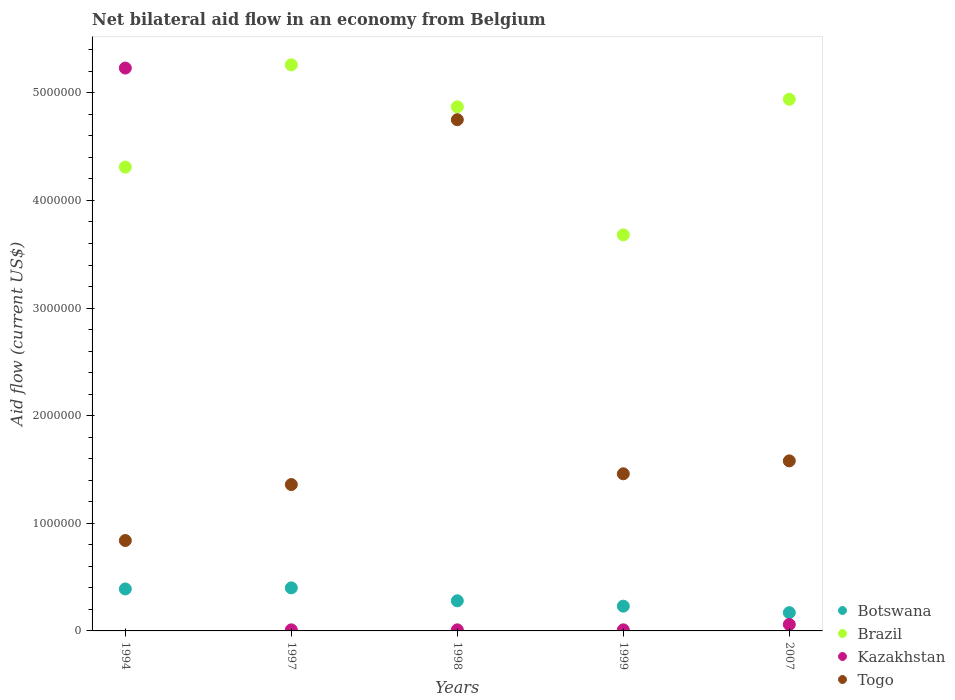Is the number of dotlines equal to the number of legend labels?
Keep it short and to the point. Yes. Across all years, what is the maximum net bilateral aid flow in Kazakhstan?
Keep it short and to the point. 5.23e+06. Across all years, what is the minimum net bilateral aid flow in Botswana?
Offer a very short reply. 1.70e+05. What is the total net bilateral aid flow in Kazakhstan in the graph?
Ensure brevity in your answer.  5.32e+06. What is the difference between the net bilateral aid flow in Botswana in 1994 and that in 1999?
Make the answer very short. 1.60e+05. What is the difference between the net bilateral aid flow in Kazakhstan in 1997 and the net bilateral aid flow in Brazil in 1999?
Your response must be concise. -3.67e+06. What is the average net bilateral aid flow in Kazakhstan per year?
Your answer should be very brief. 1.06e+06. In the year 1997, what is the difference between the net bilateral aid flow in Kazakhstan and net bilateral aid flow in Brazil?
Ensure brevity in your answer.  -5.25e+06. What is the ratio of the net bilateral aid flow in Brazil in 1999 to that in 2007?
Your response must be concise. 0.74. Is the net bilateral aid flow in Kazakhstan in 1994 less than that in 1997?
Your answer should be compact. No. What is the difference between the highest and the lowest net bilateral aid flow in Brazil?
Ensure brevity in your answer.  1.58e+06. Is it the case that in every year, the sum of the net bilateral aid flow in Togo and net bilateral aid flow in Brazil  is greater than the sum of net bilateral aid flow in Kazakhstan and net bilateral aid flow in Botswana?
Offer a very short reply. No. Is it the case that in every year, the sum of the net bilateral aid flow in Botswana and net bilateral aid flow in Kazakhstan  is greater than the net bilateral aid flow in Togo?
Give a very brief answer. No. Does the net bilateral aid flow in Kazakhstan monotonically increase over the years?
Your response must be concise. No. Is the net bilateral aid flow in Botswana strictly greater than the net bilateral aid flow in Togo over the years?
Make the answer very short. No. Is the net bilateral aid flow in Botswana strictly less than the net bilateral aid flow in Togo over the years?
Offer a terse response. Yes. How many dotlines are there?
Offer a very short reply. 4. How many years are there in the graph?
Your answer should be very brief. 5. Are the values on the major ticks of Y-axis written in scientific E-notation?
Your answer should be compact. No. Does the graph contain any zero values?
Offer a terse response. No. How many legend labels are there?
Keep it short and to the point. 4. How are the legend labels stacked?
Ensure brevity in your answer.  Vertical. What is the title of the graph?
Offer a very short reply. Net bilateral aid flow in an economy from Belgium. What is the label or title of the Y-axis?
Your response must be concise. Aid flow (current US$). What is the Aid flow (current US$) in Botswana in 1994?
Your response must be concise. 3.90e+05. What is the Aid flow (current US$) in Brazil in 1994?
Provide a succinct answer. 4.31e+06. What is the Aid flow (current US$) in Kazakhstan in 1994?
Give a very brief answer. 5.23e+06. What is the Aid flow (current US$) in Togo in 1994?
Make the answer very short. 8.40e+05. What is the Aid flow (current US$) of Botswana in 1997?
Your answer should be very brief. 4.00e+05. What is the Aid flow (current US$) of Brazil in 1997?
Provide a short and direct response. 5.26e+06. What is the Aid flow (current US$) in Togo in 1997?
Make the answer very short. 1.36e+06. What is the Aid flow (current US$) of Botswana in 1998?
Your answer should be compact. 2.80e+05. What is the Aid flow (current US$) of Brazil in 1998?
Provide a short and direct response. 4.87e+06. What is the Aid flow (current US$) in Kazakhstan in 1998?
Give a very brief answer. 10000. What is the Aid flow (current US$) of Togo in 1998?
Your answer should be compact. 4.75e+06. What is the Aid flow (current US$) in Brazil in 1999?
Offer a very short reply. 3.68e+06. What is the Aid flow (current US$) of Togo in 1999?
Offer a terse response. 1.46e+06. What is the Aid flow (current US$) of Botswana in 2007?
Your response must be concise. 1.70e+05. What is the Aid flow (current US$) in Brazil in 2007?
Provide a succinct answer. 4.94e+06. What is the Aid flow (current US$) of Togo in 2007?
Keep it short and to the point. 1.58e+06. Across all years, what is the maximum Aid flow (current US$) of Brazil?
Provide a short and direct response. 5.26e+06. Across all years, what is the maximum Aid flow (current US$) of Kazakhstan?
Give a very brief answer. 5.23e+06. Across all years, what is the maximum Aid flow (current US$) in Togo?
Give a very brief answer. 4.75e+06. Across all years, what is the minimum Aid flow (current US$) of Brazil?
Your response must be concise. 3.68e+06. Across all years, what is the minimum Aid flow (current US$) in Kazakhstan?
Your response must be concise. 10000. Across all years, what is the minimum Aid flow (current US$) in Togo?
Provide a succinct answer. 8.40e+05. What is the total Aid flow (current US$) of Botswana in the graph?
Provide a succinct answer. 1.47e+06. What is the total Aid flow (current US$) of Brazil in the graph?
Your answer should be compact. 2.31e+07. What is the total Aid flow (current US$) in Kazakhstan in the graph?
Offer a terse response. 5.32e+06. What is the total Aid flow (current US$) of Togo in the graph?
Provide a short and direct response. 9.99e+06. What is the difference between the Aid flow (current US$) in Brazil in 1994 and that in 1997?
Your answer should be compact. -9.50e+05. What is the difference between the Aid flow (current US$) of Kazakhstan in 1994 and that in 1997?
Provide a short and direct response. 5.22e+06. What is the difference between the Aid flow (current US$) in Togo in 1994 and that in 1997?
Ensure brevity in your answer.  -5.20e+05. What is the difference between the Aid flow (current US$) in Botswana in 1994 and that in 1998?
Keep it short and to the point. 1.10e+05. What is the difference between the Aid flow (current US$) of Brazil in 1994 and that in 1998?
Make the answer very short. -5.60e+05. What is the difference between the Aid flow (current US$) in Kazakhstan in 1994 and that in 1998?
Give a very brief answer. 5.22e+06. What is the difference between the Aid flow (current US$) of Togo in 1994 and that in 1998?
Provide a succinct answer. -3.91e+06. What is the difference between the Aid flow (current US$) of Brazil in 1994 and that in 1999?
Your response must be concise. 6.30e+05. What is the difference between the Aid flow (current US$) in Kazakhstan in 1994 and that in 1999?
Offer a very short reply. 5.22e+06. What is the difference between the Aid flow (current US$) of Togo in 1994 and that in 1999?
Offer a very short reply. -6.20e+05. What is the difference between the Aid flow (current US$) in Botswana in 1994 and that in 2007?
Ensure brevity in your answer.  2.20e+05. What is the difference between the Aid flow (current US$) in Brazil in 1994 and that in 2007?
Provide a short and direct response. -6.30e+05. What is the difference between the Aid flow (current US$) in Kazakhstan in 1994 and that in 2007?
Give a very brief answer. 5.17e+06. What is the difference between the Aid flow (current US$) of Togo in 1994 and that in 2007?
Offer a very short reply. -7.40e+05. What is the difference between the Aid flow (current US$) in Botswana in 1997 and that in 1998?
Ensure brevity in your answer.  1.20e+05. What is the difference between the Aid flow (current US$) in Togo in 1997 and that in 1998?
Your answer should be compact. -3.39e+06. What is the difference between the Aid flow (current US$) of Brazil in 1997 and that in 1999?
Make the answer very short. 1.58e+06. What is the difference between the Aid flow (current US$) of Kazakhstan in 1997 and that in 1999?
Offer a terse response. 0. What is the difference between the Aid flow (current US$) in Togo in 1997 and that in 1999?
Offer a terse response. -1.00e+05. What is the difference between the Aid flow (current US$) in Botswana in 1997 and that in 2007?
Give a very brief answer. 2.30e+05. What is the difference between the Aid flow (current US$) of Kazakhstan in 1997 and that in 2007?
Give a very brief answer. -5.00e+04. What is the difference between the Aid flow (current US$) of Brazil in 1998 and that in 1999?
Offer a terse response. 1.19e+06. What is the difference between the Aid flow (current US$) of Togo in 1998 and that in 1999?
Provide a short and direct response. 3.29e+06. What is the difference between the Aid flow (current US$) of Togo in 1998 and that in 2007?
Offer a terse response. 3.17e+06. What is the difference between the Aid flow (current US$) of Botswana in 1999 and that in 2007?
Give a very brief answer. 6.00e+04. What is the difference between the Aid flow (current US$) in Brazil in 1999 and that in 2007?
Give a very brief answer. -1.26e+06. What is the difference between the Aid flow (current US$) in Kazakhstan in 1999 and that in 2007?
Make the answer very short. -5.00e+04. What is the difference between the Aid flow (current US$) in Togo in 1999 and that in 2007?
Provide a short and direct response. -1.20e+05. What is the difference between the Aid flow (current US$) of Botswana in 1994 and the Aid flow (current US$) of Brazil in 1997?
Offer a very short reply. -4.87e+06. What is the difference between the Aid flow (current US$) of Botswana in 1994 and the Aid flow (current US$) of Togo in 1997?
Provide a succinct answer. -9.70e+05. What is the difference between the Aid flow (current US$) in Brazil in 1994 and the Aid flow (current US$) in Kazakhstan in 1997?
Provide a short and direct response. 4.30e+06. What is the difference between the Aid flow (current US$) in Brazil in 1994 and the Aid flow (current US$) in Togo in 1997?
Your response must be concise. 2.95e+06. What is the difference between the Aid flow (current US$) of Kazakhstan in 1994 and the Aid flow (current US$) of Togo in 1997?
Make the answer very short. 3.87e+06. What is the difference between the Aid flow (current US$) of Botswana in 1994 and the Aid flow (current US$) of Brazil in 1998?
Your answer should be compact. -4.48e+06. What is the difference between the Aid flow (current US$) of Botswana in 1994 and the Aid flow (current US$) of Kazakhstan in 1998?
Offer a terse response. 3.80e+05. What is the difference between the Aid flow (current US$) in Botswana in 1994 and the Aid flow (current US$) in Togo in 1998?
Ensure brevity in your answer.  -4.36e+06. What is the difference between the Aid flow (current US$) of Brazil in 1994 and the Aid flow (current US$) of Kazakhstan in 1998?
Offer a terse response. 4.30e+06. What is the difference between the Aid flow (current US$) of Brazil in 1994 and the Aid flow (current US$) of Togo in 1998?
Your response must be concise. -4.40e+05. What is the difference between the Aid flow (current US$) of Botswana in 1994 and the Aid flow (current US$) of Brazil in 1999?
Offer a very short reply. -3.29e+06. What is the difference between the Aid flow (current US$) in Botswana in 1994 and the Aid flow (current US$) in Kazakhstan in 1999?
Offer a terse response. 3.80e+05. What is the difference between the Aid flow (current US$) in Botswana in 1994 and the Aid flow (current US$) in Togo in 1999?
Your answer should be compact. -1.07e+06. What is the difference between the Aid flow (current US$) of Brazil in 1994 and the Aid flow (current US$) of Kazakhstan in 1999?
Provide a short and direct response. 4.30e+06. What is the difference between the Aid flow (current US$) of Brazil in 1994 and the Aid flow (current US$) of Togo in 1999?
Offer a very short reply. 2.85e+06. What is the difference between the Aid flow (current US$) in Kazakhstan in 1994 and the Aid flow (current US$) in Togo in 1999?
Give a very brief answer. 3.77e+06. What is the difference between the Aid flow (current US$) in Botswana in 1994 and the Aid flow (current US$) in Brazil in 2007?
Provide a succinct answer. -4.55e+06. What is the difference between the Aid flow (current US$) of Botswana in 1994 and the Aid flow (current US$) of Togo in 2007?
Make the answer very short. -1.19e+06. What is the difference between the Aid flow (current US$) in Brazil in 1994 and the Aid flow (current US$) in Kazakhstan in 2007?
Make the answer very short. 4.25e+06. What is the difference between the Aid flow (current US$) of Brazil in 1994 and the Aid flow (current US$) of Togo in 2007?
Give a very brief answer. 2.73e+06. What is the difference between the Aid flow (current US$) of Kazakhstan in 1994 and the Aid flow (current US$) of Togo in 2007?
Your answer should be very brief. 3.65e+06. What is the difference between the Aid flow (current US$) of Botswana in 1997 and the Aid flow (current US$) of Brazil in 1998?
Keep it short and to the point. -4.47e+06. What is the difference between the Aid flow (current US$) in Botswana in 1997 and the Aid flow (current US$) in Togo in 1998?
Your response must be concise. -4.35e+06. What is the difference between the Aid flow (current US$) in Brazil in 1997 and the Aid flow (current US$) in Kazakhstan in 1998?
Your answer should be very brief. 5.25e+06. What is the difference between the Aid flow (current US$) in Brazil in 1997 and the Aid flow (current US$) in Togo in 1998?
Give a very brief answer. 5.10e+05. What is the difference between the Aid flow (current US$) of Kazakhstan in 1997 and the Aid flow (current US$) of Togo in 1998?
Offer a terse response. -4.74e+06. What is the difference between the Aid flow (current US$) in Botswana in 1997 and the Aid flow (current US$) in Brazil in 1999?
Provide a short and direct response. -3.28e+06. What is the difference between the Aid flow (current US$) in Botswana in 1997 and the Aid flow (current US$) in Kazakhstan in 1999?
Give a very brief answer. 3.90e+05. What is the difference between the Aid flow (current US$) in Botswana in 1997 and the Aid flow (current US$) in Togo in 1999?
Make the answer very short. -1.06e+06. What is the difference between the Aid flow (current US$) of Brazil in 1997 and the Aid flow (current US$) of Kazakhstan in 1999?
Your response must be concise. 5.25e+06. What is the difference between the Aid flow (current US$) in Brazil in 1997 and the Aid flow (current US$) in Togo in 1999?
Provide a succinct answer. 3.80e+06. What is the difference between the Aid flow (current US$) in Kazakhstan in 1997 and the Aid flow (current US$) in Togo in 1999?
Provide a short and direct response. -1.45e+06. What is the difference between the Aid flow (current US$) in Botswana in 1997 and the Aid flow (current US$) in Brazil in 2007?
Make the answer very short. -4.54e+06. What is the difference between the Aid flow (current US$) of Botswana in 1997 and the Aid flow (current US$) of Kazakhstan in 2007?
Provide a short and direct response. 3.40e+05. What is the difference between the Aid flow (current US$) in Botswana in 1997 and the Aid flow (current US$) in Togo in 2007?
Keep it short and to the point. -1.18e+06. What is the difference between the Aid flow (current US$) in Brazil in 1997 and the Aid flow (current US$) in Kazakhstan in 2007?
Provide a short and direct response. 5.20e+06. What is the difference between the Aid flow (current US$) in Brazil in 1997 and the Aid flow (current US$) in Togo in 2007?
Provide a succinct answer. 3.68e+06. What is the difference between the Aid flow (current US$) in Kazakhstan in 1997 and the Aid flow (current US$) in Togo in 2007?
Offer a very short reply. -1.57e+06. What is the difference between the Aid flow (current US$) in Botswana in 1998 and the Aid flow (current US$) in Brazil in 1999?
Provide a short and direct response. -3.40e+06. What is the difference between the Aid flow (current US$) of Botswana in 1998 and the Aid flow (current US$) of Togo in 1999?
Ensure brevity in your answer.  -1.18e+06. What is the difference between the Aid flow (current US$) in Brazil in 1998 and the Aid flow (current US$) in Kazakhstan in 1999?
Make the answer very short. 4.86e+06. What is the difference between the Aid flow (current US$) in Brazil in 1998 and the Aid flow (current US$) in Togo in 1999?
Keep it short and to the point. 3.41e+06. What is the difference between the Aid flow (current US$) of Kazakhstan in 1998 and the Aid flow (current US$) of Togo in 1999?
Offer a terse response. -1.45e+06. What is the difference between the Aid flow (current US$) in Botswana in 1998 and the Aid flow (current US$) in Brazil in 2007?
Offer a very short reply. -4.66e+06. What is the difference between the Aid flow (current US$) of Botswana in 1998 and the Aid flow (current US$) of Kazakhstan in 2007?
Make the answer very short. 2.20e+05. What is the difference between the Aid flow (current US$) in Botswana in 1998 and the Aid flow (current US$) in Togo in 2007?
Your answer should be compact. -1.30e+06. What is the difference between the Aid flow (current US$) of Brazil in 1998 and the Aid flow (current US$) of Kazakhstan in 2007?
Ensure brevity in your answer.  4.81e+06. What is the difference between the Aid flow (current US$) in Brazil in 1998 and the Aid flow (current US$) in Togo in 2007?
Keep it short and to the point. 3.29e+06. What is the difference between the Aid flow (current US$) of Kazakhstan in 1998 and the Aid flow (current US$) of Togo in 2007?
Your response must be concise. -1.57e+06. What is the difference between the Aid flow (current US$) of Botswana in 1999 and the Aid flow (current US$) of Brazil in 2007?
Ensure brevity in your answer.  -4.71e+06. What is the difference between the Aid flow (current US$) in Botswana in 1999 and the Aid flow (current US$) in Togo in 2007?
Give a very brief answer. -1.35e+06. What is the difference between the Aid flow (current US$) of Brazil in 1999 and the Aid flow (current US$) of Kazakhstan in 2007?
Your answer should be compact. 3.62e+06. What is the difference between the Aid flow (current US$) of Brazil in 1999 and the Aid flow (current US$) of Togo in 2007?
Your answer should be compact. 2.10e+06. What is the difference between the Aid flow (current US$) of Kazakhstan in 1999 and the Aid flow (current US$) of Togo in 2007?
Make the answer very short. -1.57e+06. What is the average Aid flow (current US$) in Botswana per year?
Your response must be concise. 2.94e+05. What is the average Aid flow (current US$) in Brazil per year?
Make the answer very short. 4.61e+06. What is the average Aid flow (current US$) of Kazakhstan per year?
Provide a short and direct response. 1.06e+06. What is the average Aid flow (current US$) in Togo per year?
Give a very brief answer. 2.00e+06. In the year 1994, what is the difference between the Aid flow (current US$) of Botswana and Aid flow (current US$) of Brazil?
Provide a succinct answer. -3.92e+06. In the year 1994, what is the difference between the Aid flow (current US$) in Botswana and Aid flow (current US$) in Kazakhstan?
Offer a terse response. -4.84e+06. In the year 1994, what is the difference between the Aid flow (current US$) of Botswana and Aid flow (current US$) of Togo?
Provide a succinct answer. -4.50e+05. In the year 1994, what is the difference between the Aid flow (current US$) of Brazil and Aid flow (current US$) of Kazakhstan?
Keep it short and to the point. -9.20e+05. In the year 1994, what is the difference between the Aid flow (current US$) of Brazil and Aid flow (current US$) of Togo?
Offer a terse response. 3.47e+06. In the year 1994, what is the difference between the Aid flow (current US$) in Kazakhstan and Aid flow (current US$) in Togo?
Your response must be concise. 4.39e+06. In the year 1997, what is the difference between the Aid flow (current US$) of Botswana and Aid flow (current US$) of Brazil?
Your answer should be compact. -4.86e+06. In the year 1997, what is the difference between the Aid flow (current US$) of Botswana and Aid flow (current US$) of Togo?
Give a very brief answer. -9.60e+05. In the year 1997, what is the difference between the Aid flow (current US$) of Brazil and Aid flow (current US$) of Kazakhstan?
Make the answer very short. 5.25e+06. In the year 1997, what is the difference between the Aid flow (current US$) in Brazil and Aid flow (current US$) in Togo?
Offer a terse response. 3.90e+06. In the year 1997, what is the difference between the Aid flow (current US$) of Kazakhstan and Aid flow (current US$) of Togo?
Provide a short and direct response. -1.35e+06. In the year 1998, what is the difference between the Aid flow (current US$) in Botswana and Aid flow (current US$) in Brazil?
Provide a short and direct response. -4.59e+06. In the year 1998, what is the difference between the Aid flow (current US$) in Botswana and Aid flow (current US$) in Togo?
Offer a terse response. -4.47e+06. In the year 1998, what is the difference between the Aid flow (current US$) of Brazil and Aid flow (current US$) of Kazakhstan?
Offer a very short reply. 4.86e+06. In the year 1998, what is the difference between the Aid flow (current US$) of Brazil and Aid flow (current US$) of Togo?
Keep it short and to the point. 1.20e+05. In the year 1998, what is the difference between the Aid flow (current US$) in Kazakhstan and Aid flow (current US$) in Togo?
Give a very brief answer. -4.74e+06. In the year 1999, what is the difference between the Aid flow (current US$) of Botswana and Aid flow (current US$) of Brazil?
Provide a short and direct response. -3.45e+06. In the year 1999, what is the difference between the Aid flow (current US$) of Botswana and Aid flow (current US$) of Togo?
Your answer should be very brief. -1.23e+06. In the year 1999, what is the difference between the Aid flow (current US$) of Brazil and Aid flow (current US$) of Kazakhstan?
Give a very brief answer. 3.67e+06. In the year 1999, what is the difference between the Aid flow (current US$) in Brazil and Aid flow (current US$) in Togo?
Provide a short and direct response. 2.22e+06. In the year 1999, what is the difference between the Aid flow (current US$) of Kazakhstan and Aid flow (current US$) of Togo?
Ensure brevity in your answer.  -1.45e+06. In the year 2007, what is the difference between the Aid flow (current US$) of Botswana and Aid flow (current US$) of Brazil?
Provide a short and direct response. -4.77e+06. In the year 2007, what is the difference between the Aid flow (current US$) of Botswana and Aid flow (current US$) of Kazakhstan?
Offer a terse response. 1.10e+05. In the year 2007, what is the difference between the Aid flow (current US$) in Botswana and Aid flow (current US$) in Togo?
Provide a short and direct response. -1.41e+06. In the year 2007, what is the difference between the Aid flow (current US$) of Brazil and Aid flow (current US$) of Kazakhstan?
Offer a very short reply. 4.88e+06. In the year 2007, what is the difference between the Aid flow (current US$) in Brazil and Aid flow (current US$) in Togo?
Ensure brevity in your answer.  3.36e+06. In the year 2007, what is the difference between the Aid flow (current US$) of Kazakhstan and Aid flow (current US$) of Togo?
Ensure brevity in your answer.  -1.52e+06. What is the ratio of the Aid flow (current US$) of Botswana in 1994 to that in 1997?
Your answer should be very brief. 0.97. What is the ratio of the Aid flow (current US$) of Brazil in 1994 to that in 1997?
Provide a short and direct response. 0.82. What is the ratio of the Aid flow (current US$) in Kazakhstan in 1994 to that in 1997?
Your response must be concise. 523. What is the ratio of the Aid flow (current US$) in Togo in 1994 to that in 1997?
Offer a terse response. 0.62. What is the ratio of the Aid flow (current US$) in Botswana in 1994 to that in 1998?
Offer a terse response. 1.39. What is the ratio of the Aid flow (current US$) in Brazil in 1994 to that in 1998?
Your answer should be very brief. 0.89. What is the ratio of the Aid flow (current US$) of Kazakhstan in 1994 to that in 1998?
Your answer should be compact. 523. What is the ratio of the Aid flow (current US$) of Togo in 1994 to that in 1998?
Offer a terse response. 0.18. What is the ratio of the Aid flow (current US$) of Botswana in 1994 to that in 1999?
Your answer should be very brief. 1.7. What is the ratio of the Aid flow (current US$) of Brazil in 1994 to that in 1999?
Offer a very short reply. 1.17. What is the ratio of the Aid flow (current US$) in Kazakhstan in 1994 to that in 1999?
Offer a terse response. 523. What is the ratio of the Aid flow (current US$) in Togo in 1994 to that in 1999?
Your response must be concise. 0.58. What is the ratio of the Aid flow (current US$) in Botswana in 1994 to that in 2007?
Give a very brief answer. 2.29. What is the ratio of the Aid flow (current US$) of Brazil in 1994 to that in 2007?
Make the answer very short. 0.87. What is the ratio of the Aid flow (current US$) of Kazakhstan in 1994 to that in 2007?
Offer a terse response. 87.17. What is the ratio of the Aid flow (current US$) of Togo in 1994 to that in 2007?
Offer a very short reply. 0.53. What is the ratio of the Aid flow (current US$) in Botswana in 1997 to that in 1998?
Offer a very short reply. 1.43. What is the ratio of the Aid flow (current US$) in Brazil in 1997 to that in 1998?
Provide a short and direct response. 1.08. What is the ratio of the Aid flow (current US$) of Togo in 1997 to that in 1998?
Ensure brevity in your answer.  0.29. What is the ratio of the Aid flow (current US$) in Botswana in 1997 to that in 1999?
Your answer should be very brief. 1.74. What is the ratio of the Aid flow (current US$) in Brazil in 1997 to that in 1999?
Keep it short and to the point. 1.43. What is the ratio of the Aid flow (current US$) in Togo in 1997 to that in 1999?
Provide a short and direct response. 0.93. What is the ratio of the Aid flow (current US$) of Botswana in 1997 to that in 2007?
Provide a short and direct response. 2.35. What is the ratio of the Aid flow (current US$) in Brazil in 1997 to that in 2007?
Make the answer very short. 1.06. What is the ratio of the Aid flow (current US$) of Togo in 1997 to that in 2007?
Provide a short and direct response. 0.86. What is the ratio of the Aid flow (current US$) of Botswana in 1998 to that in 1999?
Your response must be concise. 1.22. What is the ratio of the Aid flow (current US$) of Brazil in 1998 to that in 1999?
Ensure brevity in your answer.  1.32. What is the ratio of the Aid flow (current US$) of Togo in 1998 to that in 1999?
Offer a very short reply. 3.25. What is the ratio of the Aid flow (current US$) in Botswana in 1998 to that in 2007?
Ensure brevity in your answer.  1.65. What is the ratio of the Aid flow (current US$) of Brazil in 1998 to that in 2007?
Your answer should be compact. 0.99. What is the ratio of the Aid flow (current US$) in Kazakhstan in 1998 to that in 2007?
Offer a very short reply. 0.17. What is the ratio of the Aid flow (current US$) of Togo in 1998 to that in 2007?
Ensure brevity in your answer.  3.01. What is the ratio of the Aid flow (current US$) in Botswana in 1999 to that in 2007?
Provide a short and direct response. 1.35. What is the ratio of the Aid flow (current US$) in Brazil in 1999 to that in 2007?
Provide a short and direct response. 0.74. What is the ratio of the Aid flow (current US$) of Kazakhstan in 1999 to that in 2007?
Your response must be concise. 0.17. What is the ratio of the Aid flow (current US$) of Togo in 1999 to that in 2007?
Offer a terse response. 0.92. What is the difference between the highest and the second highest Aid flow (current US$) of Botswana?
Keep it short and to the point. 10000. What is the difference between the highest and the second highest Aid flow (current US$) of Brazil?
Offer a terse response. 3.20e+05. What is the difference between the highest and the second highest Aid flow (current US$) in Kazakhstan?
Keep it short and to the point. 5.17e+06. What is the difference between the highest and the second highest Aid flow (current US$) in Togo?
Provide a succinct answer. 3.17e+06. What is the difference between the highest and the lowest Aid flow (current US$) in Botswana?
Your answer should be compact. 2.30e+05. What is the difference between the highest and the lowest Aid flow (current US$) of Brazil?
Offer a very short reply. 1.58e+06. What is the difference between the highest and the lowest Aid flow (current US$) in Kazakhstan?
Offer a very short reply. 5.22e+06. What is the difference between the highest and the lowest Aid flow (current US$) in Togo?
Ensure brevity in your answer.  3.91e+06. 